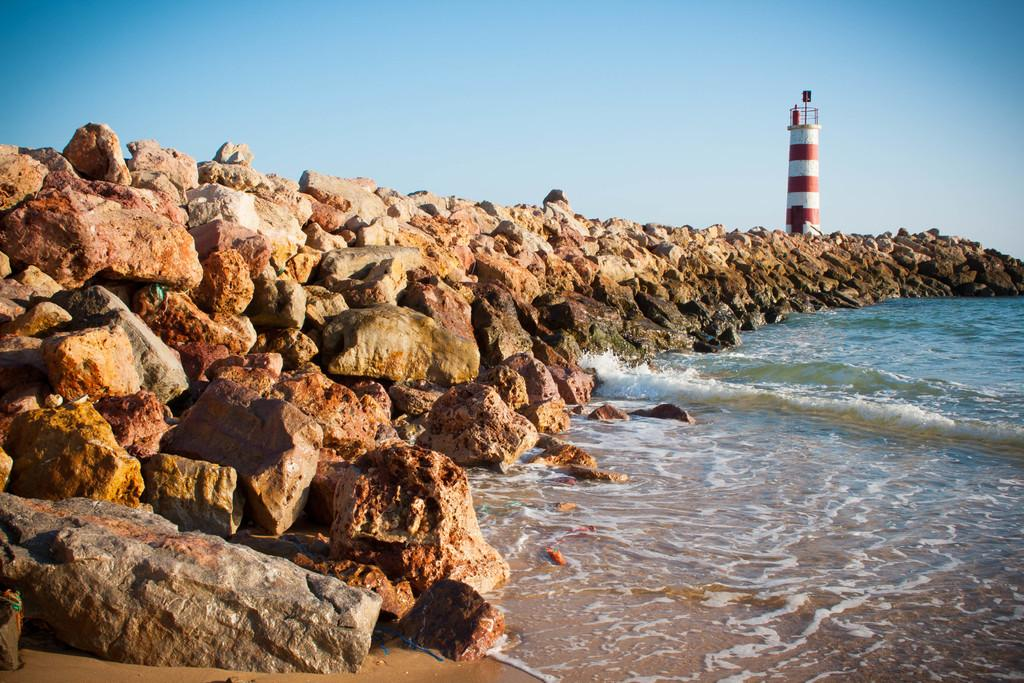What type of location is shown in the image? The image depicts a beach. What can be seen in the middle of the image? There are rocks in the middle of the image. What structure is visible in the top right of the image? There is a lighthouse in the top right of the image. What is visible at the top of the image? There is a screen visible at the top of the image. Can you tell me how many kittens are playing with the grandfather and the boy in the image? There are no kittens, grandfather, or boy present in the image; it depicts a beach with rocks and a lighthouse. 